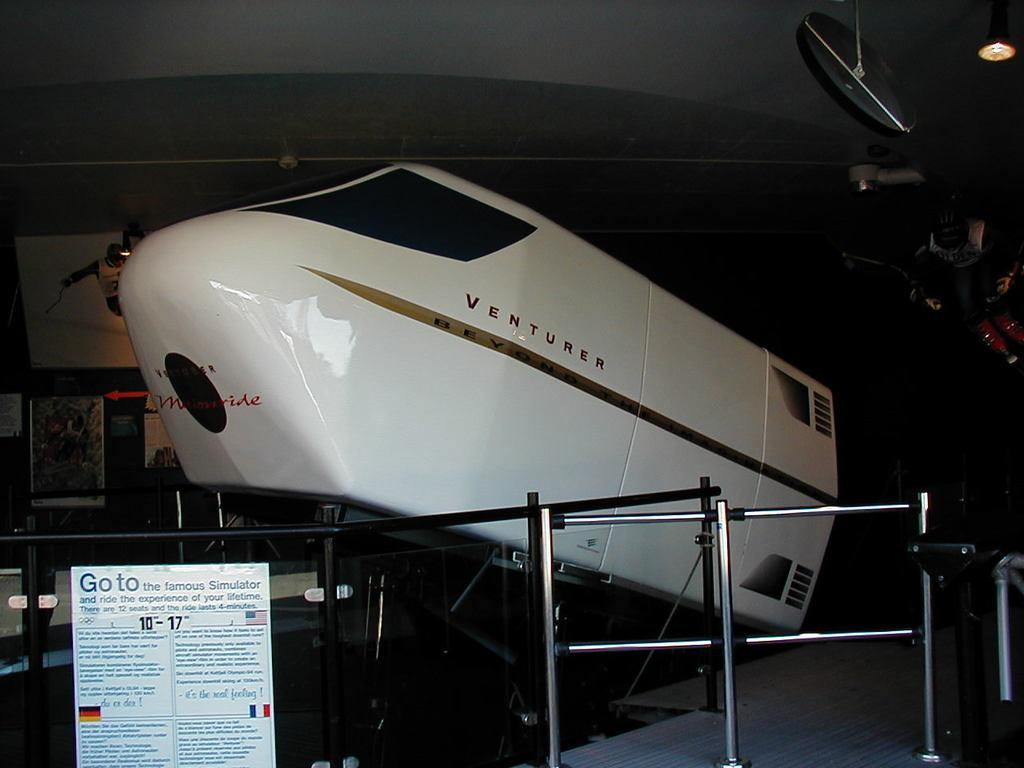<image>
Render a clear and concise summary of the photo. The word "VENTURER" is painted onto the airplane on display. 